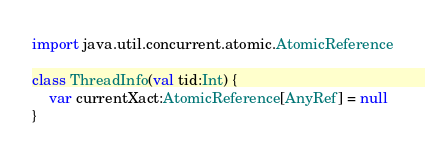Convert code to text. <code><loc_0><loc_0><loc_500><loc_500><_Scala_>import java.util.concurrent.atomic.AtomicReference

class ThreadInfo(val tid:Int) {
	var currentXact:AtomicReference[AnyRef] = null
}
</code> 